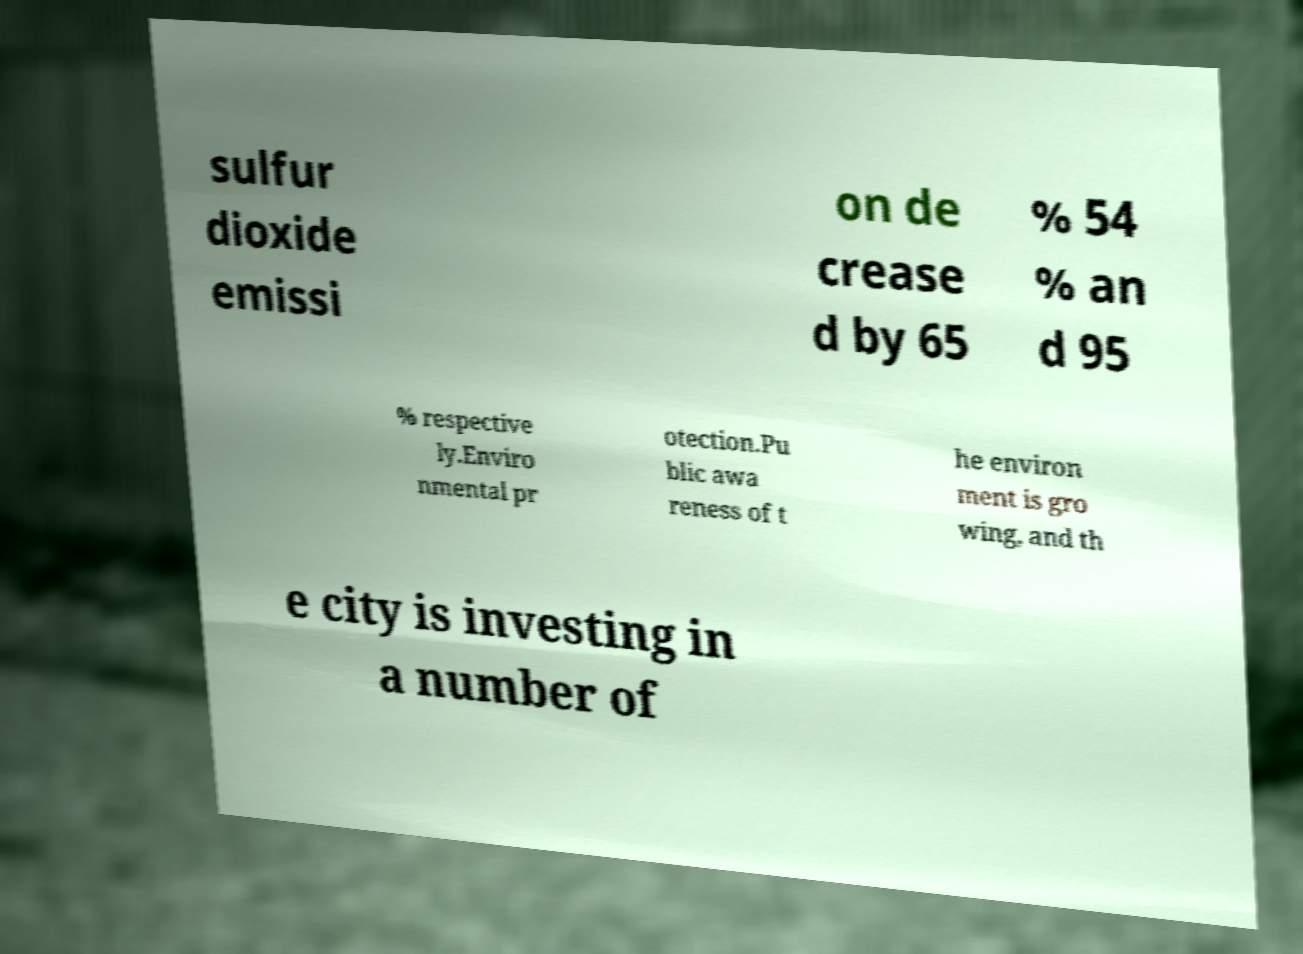There's text embedded in this image that I need extracted. Can you transcribe it verbatim? sulfur dioxide emissi on de crease d by 65 % 54 % an d 95 % respective ly.Enviro nmental pr otection.Pu blic awa reness of t he environ ment is gro wing, and th e city is investing in a number of 